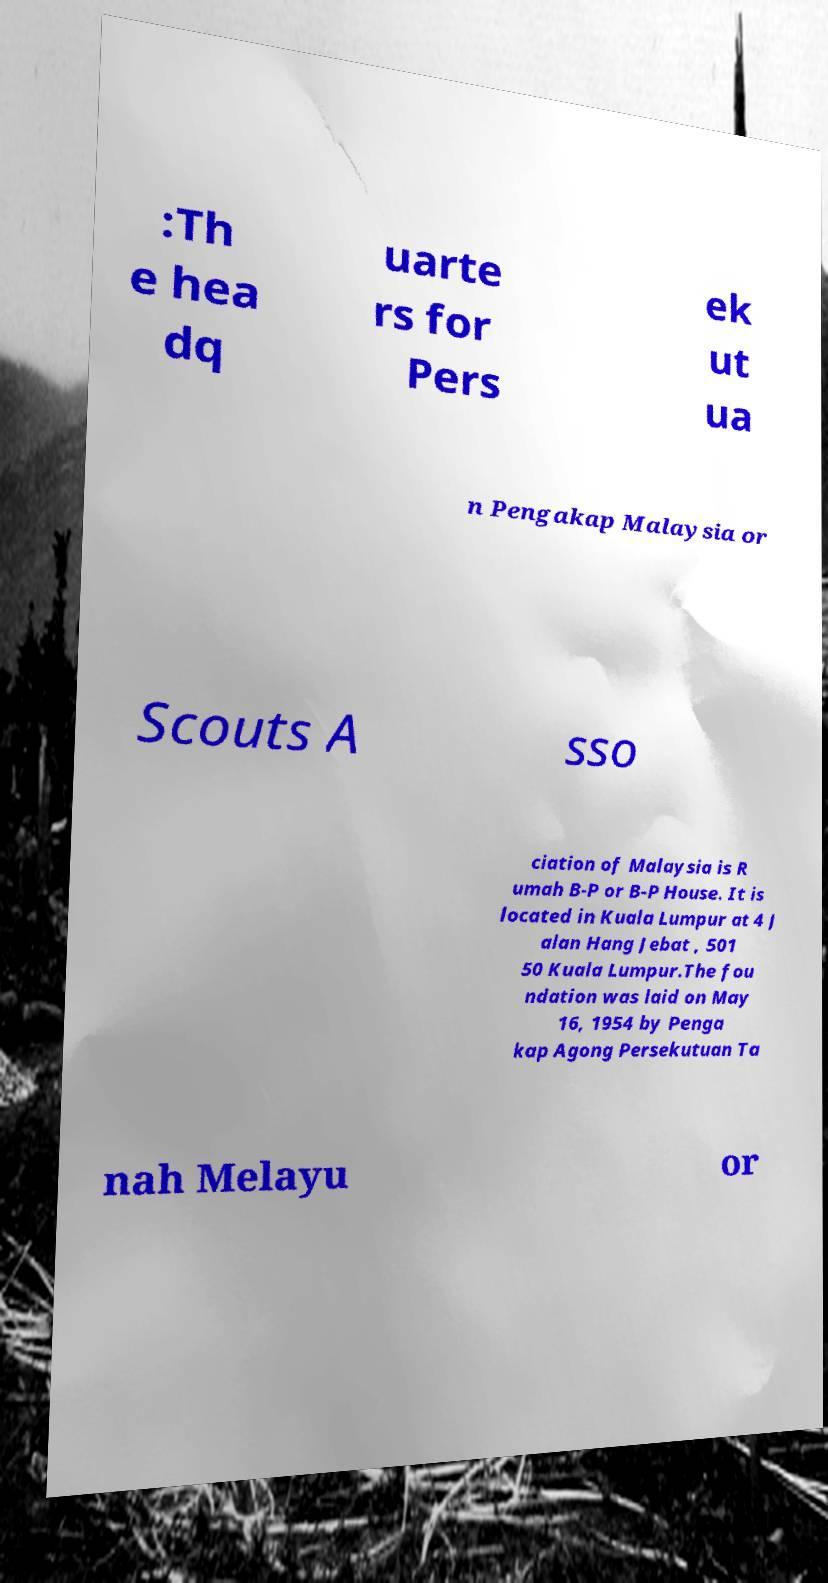Can you read and provide the text displayed in the image?This photo seems to have some interesting text. Can you extract and type it out for me? :Th e hea dq uarte rs for Pers ek ut ua n Pengakap Malaysia or Scouts A sso ciation of Malaysia is R umah B-P or B-P House. It is located in Kuala Lumpur at 4 J alan Hang Jebat , 501 50 Kuala Lumpur.The fou ndation was laid on May 16, 1954 by Penga kap Agong Persekutuan Ta nah Melayu or 